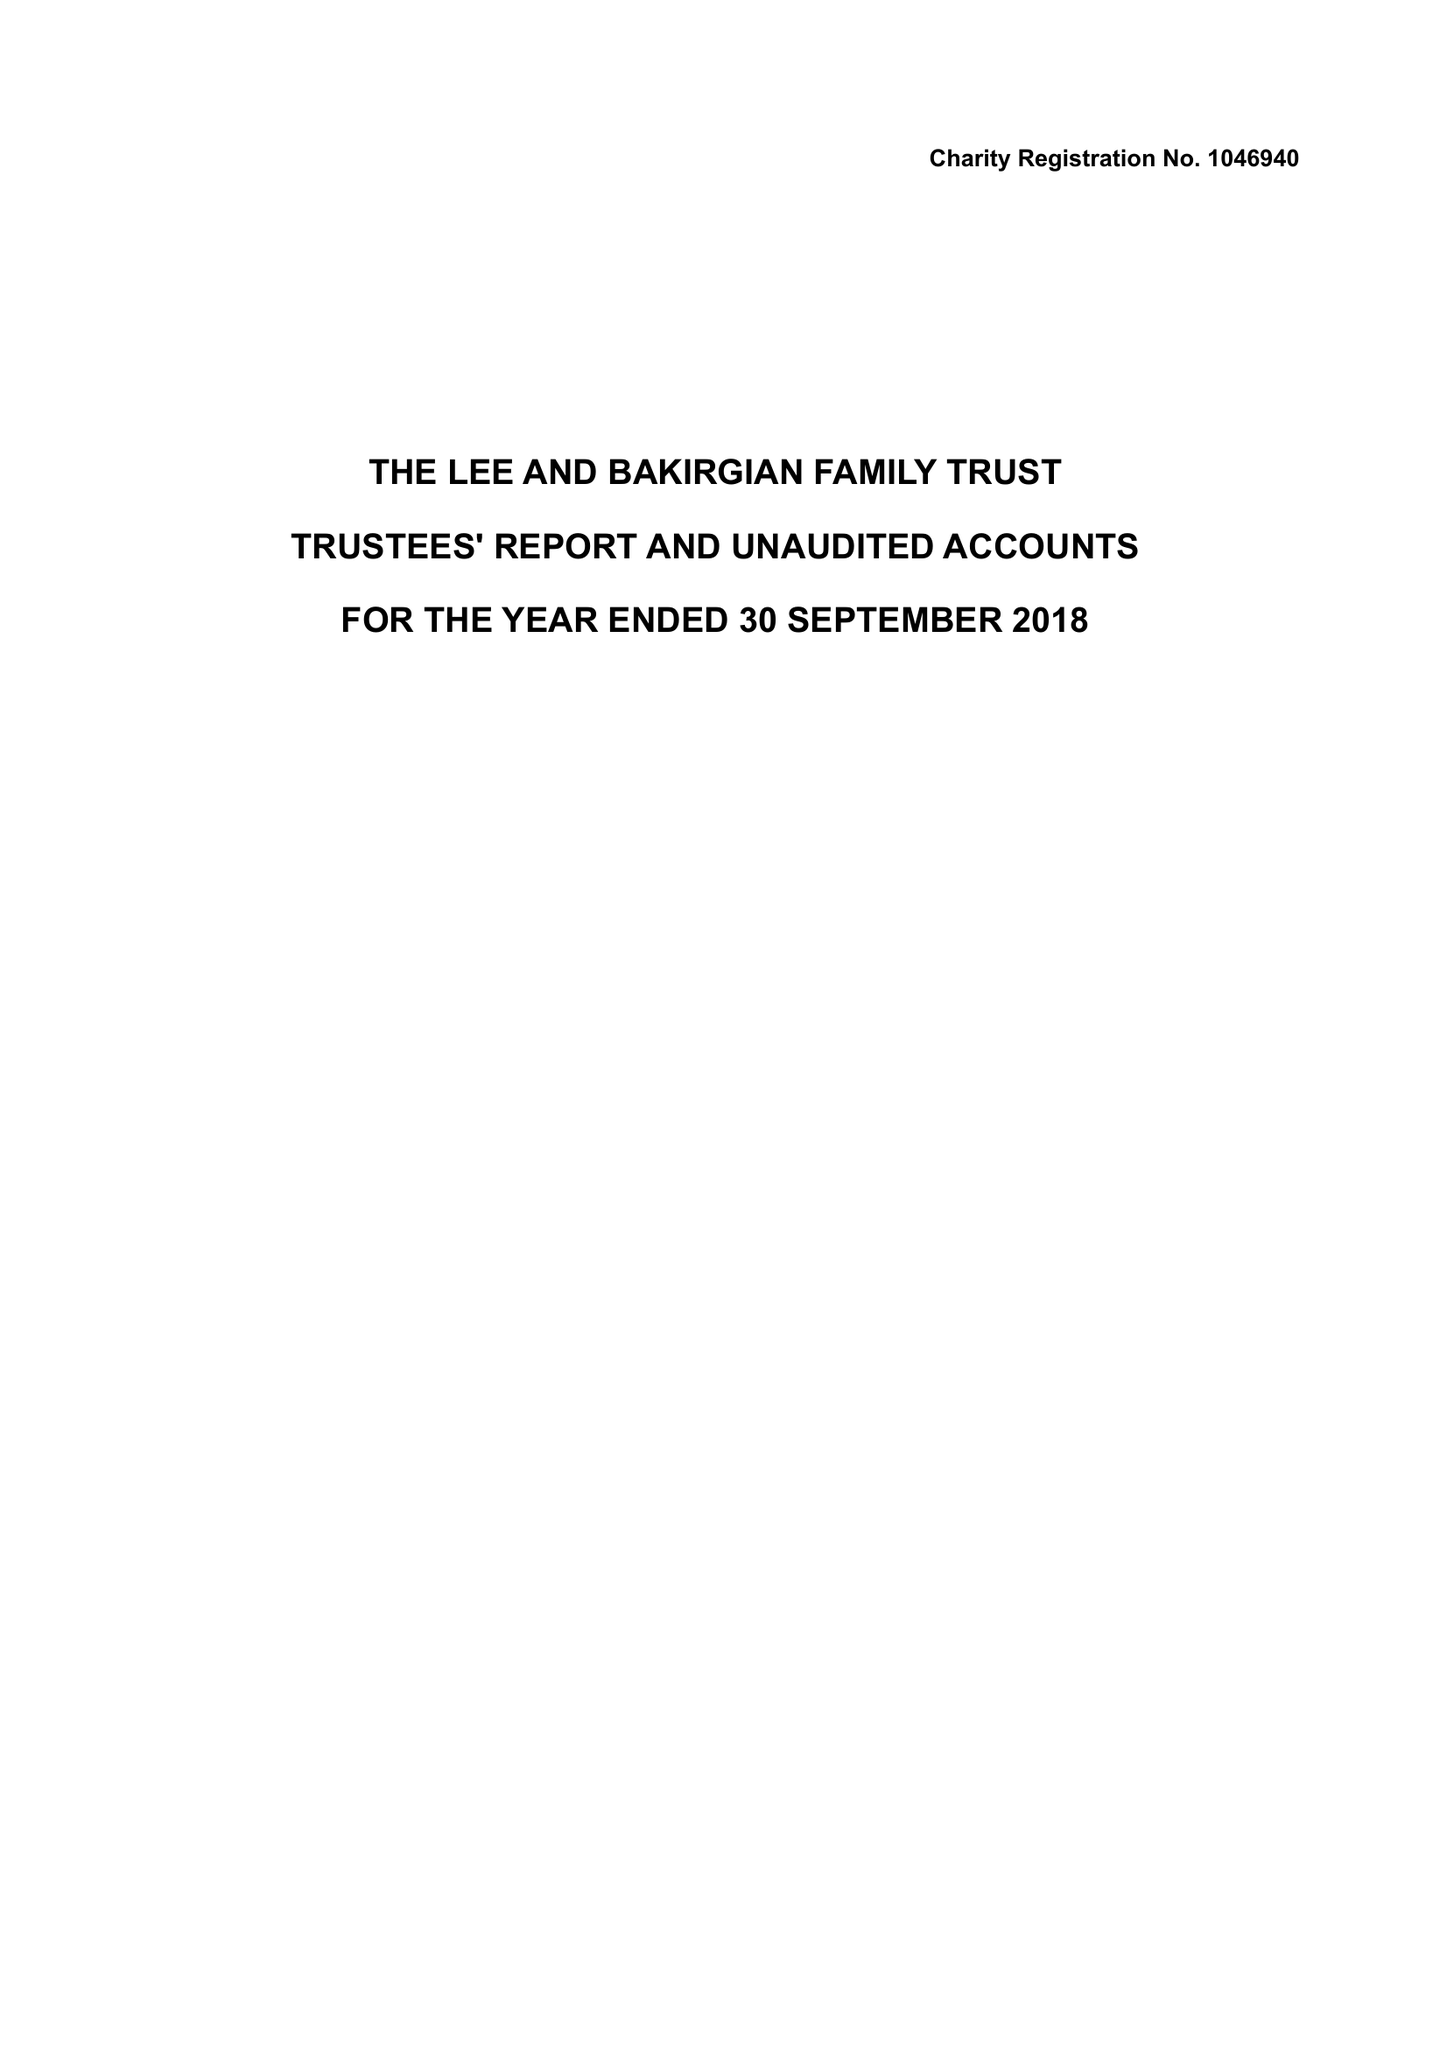What is the value for the report_date?
Answer the question using a single word or phrase. 2018-09-30 